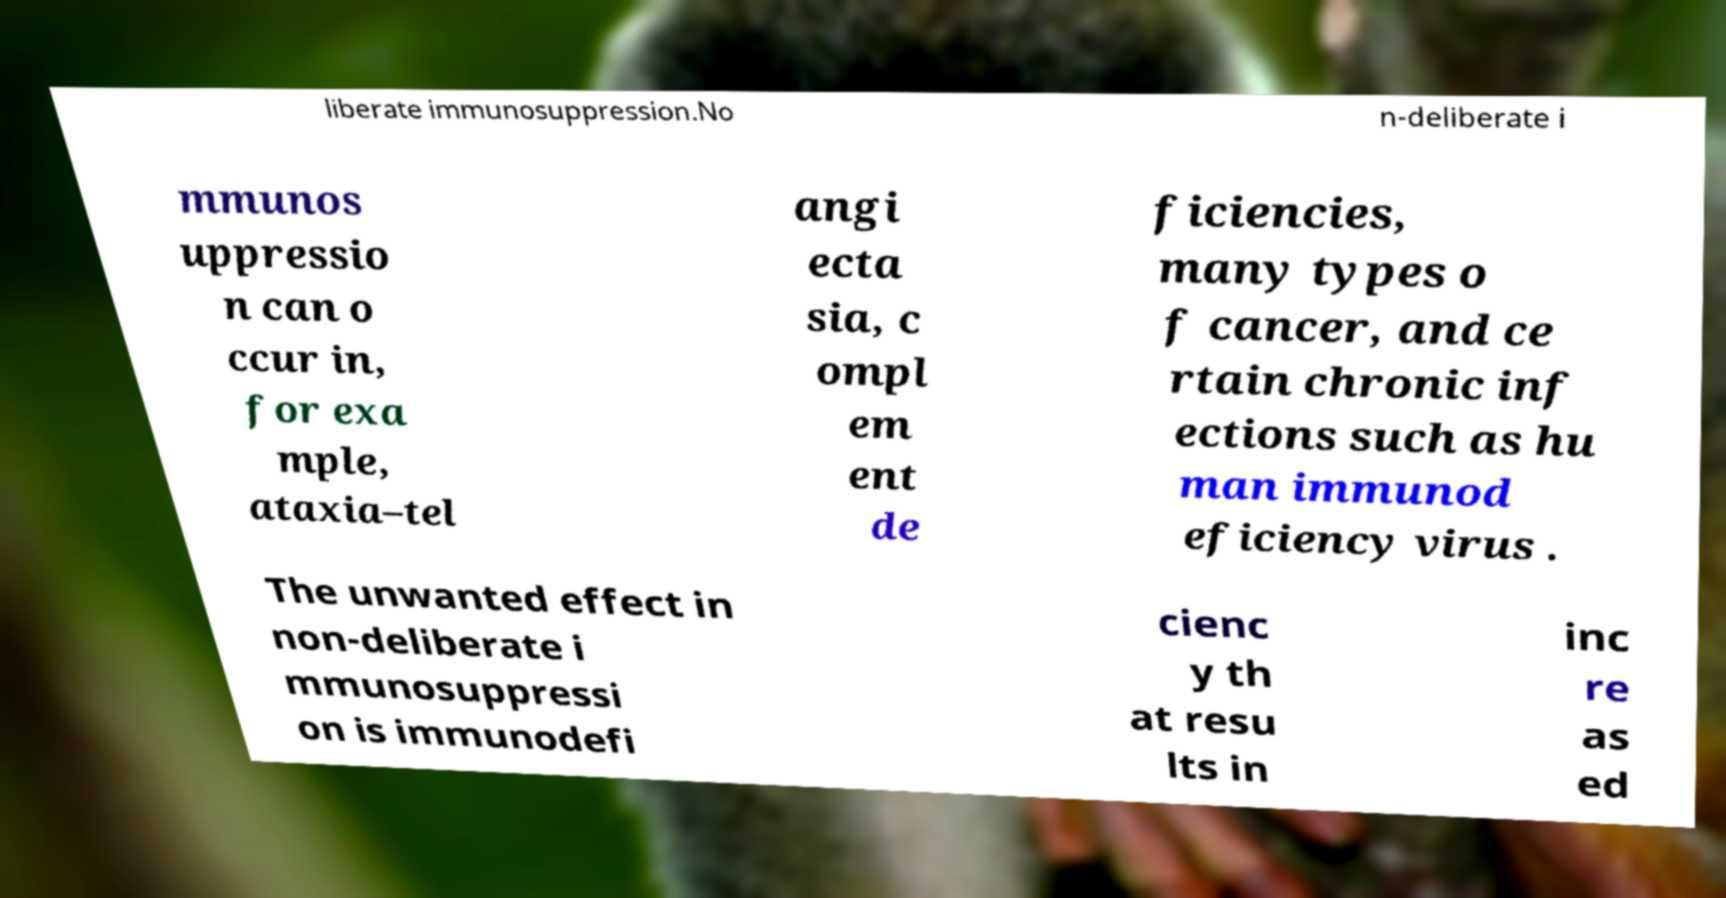Please read and relay the text visible in this image. What does it say? liberate immunosuppression.No n-deliberate i mmunos uppressio n can o ccur in, for exa mple, ataxia–tel angi ecta sia, c ompl em ent de ficiencies, many types o f cancer, and ce rtain chronic inf ections such as hu man immunod eficiency virus . The unwanted effect in non-deliberate i mmunosuppressi on is immunodefi cienc y th at resu lts in inc re as ed 